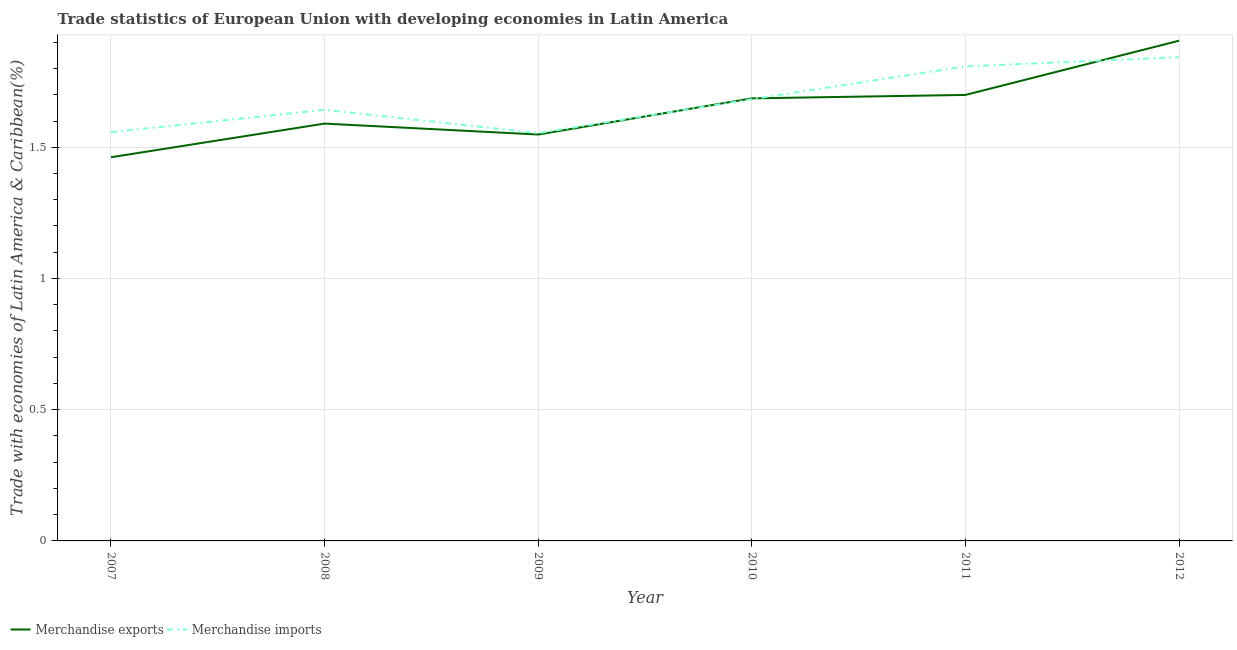How many different coloured lines are there?
Your answer should be compact. 2. What is the merchandise imports in 2010?
Provide a short and direct response. 1.68. Across all years, what is the maximum merchandise exports?
Keep it short and to the point. 1.91. Across all years, what is the minimum merchandise imports?
Your answer should be compact. 1.55. In which year was the merchandise exports minimum?
Make the answer very short. 2007. What is the total merchandise exports in the graph?
Provide a short and direct response. 9.89. What is the difference between the merchandise exports in 2009 and that in 2012?
Offer a very short reply. -0.36. What is the difference between the merchandise imports in 2007 and the merchandise exports in 2009?
Your answer should be very brief. 0.01. What is the average merchandise exports per year?
Your response must be concise. 1.65. In the year 2012, what is the difference between the merchandise exports and merchandise imports?
Your answer should be very brief. 0.06. What is the ratio of the merchandise imports in 2007 to that in 2012?
Offer a very short reply. 0.85. What is the difference between the highest and the second highest merchandise exports?
Provide a succinct answer. 0.21. What is the difference between the highest and the lowest merchandise imports?
Give a very brief answer. 0.29. Does the merchandise exports monotonically increase over the years?
Offer a very short reply. No. Is the merchandise imports strictly less than the merchandise exports over the years?
Make the answer very short. No. How many years are there in the graph?
Keep it short and to the point. 6. Are the values on the major ticks of Y-axis written in scientific E-notation?
Provide a succinct answer. No. Does the graph contain grids?
Keep it short and to the point. Yes. What is the title of the graph?
Offer a very short reply. Trade statistics of European Union with developing economies in Latin America. Does "Nonresident" appear as one of the legend labels in the graph?
Your answer should be compact. No. What is the label or title of the X-axis?
Make the answer very short. Year. What is the label or title of the Y-axis?
Your answer should be very brief. Trade with economies of Latin America & Caribbean(%). What is the Trade with economies of Latin America & Caribbean(%) of Merchandise exports in 2007?
Make the answer very short. 1.46. What is the Trade with economies of Latin America & Caribbean(%) in Merchandise imports in 2007?
Provide a succinct answer. 1.56. What is the Trade with economies of Latin America & Caribbean(%) of Merchandise exports in 2008?
Your answer should be very brief. 1.59. What is the Trade with economies of Latin America & Caribbean(%) of Merchandise imports in 2008?
Make the answer very short. 1.64. What is the Trade with economies of Latin America & Caribbean(%) in Merchandise exports in 2009?
Your response must be concise. 1.55. What is the Trade with economies of Latin America & Caribbean(%) in Merchandise imports in 2009?
Provide a short and direct response. 1.55. What is the Trade with economies of Latin America & Caribbean(%) of Merchandise exports in 2010?
Give a very brief answer. 1.69. What is the Trade with economies of Latin America & Caribbean(%) in Merchandise imports in 2010?
Keep it short and to the point. 1.68. What is the Trade with economies of Latin America & Caribbean(%) of Merchandise exports in 2011?
Give a very brief answer. 1.7. What is the Trade with economies of Latin America & Caribbean(%) of Merchandise imports in 2011?
Make the answer very short. 1.81. What is the Trade with economies of Latin America & Caribbean(%) of Merchandise exports in 2012?
Make the answer very short. 1.91. What is the Trade with economies of Latin America & Caribbean(%) in Merchandise imports in 2012?
Provide a succinct answer. 1.84. Across all years, what is the maximum Trade with economies of Latin America & Caribbean(%) of Merchandise exports?
Your answer should be compact. 1.91. Across all years, what is the maximum Trade with economies of Latin America & Caribbean(%) in Merchandise imports?
Offer a terse response. 1.84. Across all years, what is the minimum Trade with economies of Latin America & Caribbean(%) in Merchandise exports?
Keep it short and to the point. 1.46. Across all years, what is the minimum Trade with economies of Latin America & Caribbean(%) in Merchandise imports?
Offer a terse response. 1.55. What is the total Trade with economies of Latin America & Caribbean(%) of Merchandise exports in the graph?
Your answer should be very brief. 9.89. What is the total Trade with economies of Latin America & Caribbean(%) of Merchandise imports in the graph?
Keep it short and to the point. 10.09. What is the difference between the Trade with economies of Latin America & Caribbean(%) in Merchandise exports in 2007 and that in 2008?
Keep it short and to the point. -0.13. What is the difference between the Trade with economies of Latin America & Caribbean(%) of Merchandise imports in 2007 and that in 2008?
Make the answer very short. -0.09. What is the difference between the Trade with economies of Latin America & Caribbean(%) in Merchandise exports in 2007 and that in 2009?
Your answer should be very brief. -0.09. What is the difference between the Trade with economies of Latin America & Caribbean(%) of Merchandise imports in 2007 and that in 2009?
Give a very brief answer. 0. What is the difference between the Trade with economies of Latin America & Caribbean(%) in Merchandise exports in 2007 and that in 2010?
Provide a short and direct response. -0.22. What is the difference between the Trade with economies of Latin America & Caribbean(%) of Merchandise imports in 2007 and that in 2010?
Give a very brief answer. -0.13. What is the difference between the Trade with economies of Latin America & Caribbean(%) of Merchandise exports in 2007 and that in 2011?
Keep it short and to the point. -0.24. What is the difference between the Trade with economies of Latin America & Caribbean(%) in Merchandise imports in 2007 and that in 2011?
Make the answer very short. -0.25. What is the difference between the Trade with economies of Latin America & Caribbean(%) of Merchandise exports in 2007 and that in 2012?
Make the answer very short. -0.44. What is the difference between the Trade with economies of Latin America & Caribbean(%) of Merchandise imports in 2007 and that in 2012?
Your response must be concise. -0.29. What is the difference between the Trade with economies of Latin America & Caribbean(%) in Merchandise exports in 2008 and that in 2009?
Give a very brief answer. 0.04. What is the difference between the Trade with economies of Latin America & Caribbean(%) of Merchandise imports in 2008 and that in 2009?
Give a very brief answer. 0.09. What is the difference between the Trade with economies of Latin America & Caribbean(%) in Merchandise exports in 2008 and that in 2010?
Your answer should be very brief. -0.1. What is the difference between the Trade with economies of Latin America & Caribbean(%) in Merchandise imports in 2008 and that in 2010?
Your response must be concise. -0.04. What is the difference between the Trade with economies of Latin America & Caribbean(%) of Merchandise exports in 2008 and that in 2011?
Offer a terse response. -0.11. What is the difference between the Trade with economies of Latin America & Caribbean(%) of Merchandise imports in 2008 and that in 2011?
Your answer should be compact. -0.17. What is the difference between the Trade with economies of Latin America & Caribbean(%) of Merchandise exports in 2008 and that in 2012?
Ensure brevity in your answer.  -0.32. What is the difference between the Trade with economies of Latin America & Caribbean(%) in Merchandise imports in 2008 and that in 2012?
Give a very brief answer. -0.2. What is the difference between the Trade with economies of Latin America & Caribbean(%) in Merchandise exports in 2009 and that in 2010?
Your answer should be compact. -0.14. What is the difference between the Trade with economies of Latin America & Caribbean(%) in Merchandise imports in 2009 and that in 2010?
Make the answer very short. -0.13. What is the difference between the Trade with economies of Latin America & Caribbean(%) of Merchandise exports in 2009 and that in 2011?
Offer a terse response. -0.15. What is the difference between the Trade with economies of Latin America & Caribbean(%) in Merchandise imports in 2009 and that in 2011?
Give a very brief answer. -0.25. What is the difference between the Trade with economies of Latin America & Caribbean(%) of Merchandise exports in 2009 and that in 2012?
Provide a succinct answer. -0.36. What is the difference between the Trade with economies of Latin America & Caribbean(%) of Merchandise imports in 2009 and that in 2012?
Keep it short and to the point. -0.29. What is the difference between the Trade with economies of Latin America & Caribbean(%) of Merchandise exports in 2010 and that in 2011?
Give a very brief answer. -0.01. What is the difference between the Trade with economies of Latin America & Caribbean(%) in Merchandise imports in 2010 and that in 2011?
Keep it short and to the point. -0.12. What is the difference between the Trade with economies of Latin America & Caribbean(%) in Merchandise exports in 2010 and that in 2012?
Your response must be concise. -0.22. What is the difference between the Trade with economies of Latin America & Caribbean(%) of Merchandise imports in 2010 and that in 2012?
Provide a short and direct response. -0.16. What is the difference between the Trade with economies of Latin America & Caribbean(%) in Merchandise exports in 2011 and that in 2012?
Provide a short and direct response. -0.21. What is the difference between the Trade with economies of Latin America & Caribbean(%) of Merchandise imports in 2011 and that in 2012?
Ensure brevity in your answer.  -0.04. What is the difference between the Trade with economies of Latin America & Caribbean(%) in Merchandise exports in 2007 and the Trade with economies of Latin America & Caribbean(%) in Merchandise imports in 2008?
Give a very brief answer. -0.18. What is the difference between the Trade with economies of Latin America & Caribbean(%) of Merchandise exports in 2007 and the Trade with economies of Latin America & Caribbean(%) of Merchandise imports in 2009?
Your answer should be compact. -0.09. What is the difference between the Trade with economies of Latin America & Caribbean(%) in Merchandise exports in 2007 and the Trade with economies of Latin America & Caribbean(%) in Merchandise imports in 2010?
Give a very brief answer. -0.22. What is the difference between the Trade with economies of Latin America & Caribbean(%) of Merchandise exports in 2007 and the Trade with economies of Latin America & Caribbean(%) of Merchandise imports in 2011?
Offer a terse response. -0.35. What is the difference between the Trade with economies of Latin America & Caribbean(%) of Merchandise exports in 2007 and the Trade with economies of Latin America & Caribbean(%) of Merchandise imports in 2012?
Give a very brief answer. -0.38. What is the difference between the Trade with economies of Latin America & Caribbean(%) in Merchandise exports in 2008 and the Trade with economies of Latin America & Caribbean(%) in Merchandise imports in 2009?
Your response must be concise. 0.04. What is the difference between the Trade with economies of Latin America & Caribbean(%) in Merchandise exports in 2008 and the Trade with economies of Latin America & Caribbean(%) in Merchandise imports in 2010?
Your response must be concise. -0.09. What is the difference between the Trade with economies of Latin America & Caribbean(%) in Merchandise exports in 2008 and the Trade with economies of Latin America & Caribbean(%) in Merchandise imports in 2011?
Ensure brevity in your answer.  -0.22. What is the difference between the Trade with economies of Latin America & Caribbean(%) in Merchandise exports in 2008 and the Trade with economies of Latin America & Caribbean(%) in Merchandise imports in 2012?
Your response must be concise. -0.25. What is the difference between the Trade with economies of Latin America & Caribbean(%) of Merchandise exports in 2009 and the Trade with economies of Latin America & Caribbean(%) of Merchandise imports in 2010?
Offer a very short reply. -0.13. What is the difference between the Trade with economies of Latin America & Caribbean(%) in Merchandise exports in 2009 and the Trade with economies of Latin America & Caribbean(%) in Merchandise imports in 2011?
Your answer should be very brief. -0.26. What is the difference between the Trade with economies of Latin America & Caribbean(%) of Merchandise exports in 2009 and the Trade with economies of Latin America & Caribbean(%) of Merchandise imports in 2012?
Provide a succinct answer. -0.29. What is the difference between the Trade with economies of Latin America & Caribbean(%) in Merchandise exports in 2010 and the Trade with economies of Latin America & Caribbean(%) in Merchandise imports in 2011?
Offer a terse response. -0.12. What is the difference between the Trade with economies of Latin America & Caribbean(%) of Merchandise exports in 2010 and the Trade with economies of Latin America & Caribbean(%) of Merchandise imports in 2012?
Provide a succinct answer. -0.16. What is the difference between the Trade with economies of Latin America & Caribbean(%) in Merchandise exports in 2011 and the Trade with economies of Latin America & Caribbean(%) in Merchandise imports in 2012?
Your answer should be compact. -0.14. What is the average Trade with economies of Latin America & Caribbean(%) of Merchandise exports per year?
Provide a succinct answer. 1.65. What is the average Trade with economies of Latin America & Caribbean(%) of Merchandise imports per year?
Your response must be concise. 1.68. In the year 2007, what is the difference between the Trade with economies of Latin America & Caribbean(%) in Merchandise exports and Trade with economies of Latin America & Caribbean(%) in Merchandise imports?
Your response must be concise. -0.1. In the year 2008, what is the difference between the Trade with economies of Latin America & Caribbean(%) in Merchandise exports and Trade with economies of Latin America & Caribbean(%) in Merchandise imports?
Your response must be concise. -0.05. In the year 2009, what is the difference between the Trade with economies of Latin America & Caribbean(%) of Merchandise exports and Trade with economies of Latin America & Caribbean(%) of Merchandise imports?
Give a very brief answer. -0.01. In the year 2010, what is the difference between the Trade with economies of Latin America & Caribbean(%) in Merchandise exports and Trade with economies of Latin America & Caribbean(%) in Merchandise imports?
Your response must be concise. 0. In the year 2011, what is the difference between the Trade with economies of Latin America & Caribbean(%) in Merchandise exports and Trade with economies of Latin America & Caribbean(%) in Merchandise imports?
Your response must be concise. -0.11. In the year 2012, what is the difference between the Trade with economies of Latin America & Caribbean(%) in Merchandise exports and Trade with economies of Latin America & Caribbean(%) in Merchandise imports?
Offer a terse response. 0.06. What is the ratio of the Trade with economies of Latin America & Caribbean(%) of Merchandise exports in 2007 to that in 2008?
Give a very brief answer. 0.92. What is the ratio of the Trade with economies of Latin America & Caribbean(%) of Merchandise imports in 2007 to that in 2008?
Make the answer very short. 0.95. What is the ratio of the Trade with economies of Latin America & Caribbean(%) in Merchandise exports in 2007 to that in 2009?
Make the answer very short. 0.94. What is the ratio of the Trade with economies of Latin America & Caribbean(%) in Merchandise exports in 2007 to that in 2010?
Make the answer very short. 0.87. What is the ratio of the Trade with economies of Latin America & Caribbean(%) in Merchandise imports in 2007 to that in 2010?
Provide a short and direct response. 0.93. What is the ratio of the Trade with economies of Latin America & Caribbean(%) in Merchandise exports in 2007 to that in 2011?
Give a very brief answer. 0.86. What is the ratio of the Trade with economies of Latin America & Caribbean(%) of Merchandise imports in 2007 to that in 2011?
Your response must be concise. 0.86. What is the ratio of the Trade with economies of Latin America & Caribbean(%) in Merchandise exports in 2007 to that in 2012?
Your answer should be very brief. 0.77. What is the ratio of the Trade with economies of Latin America & Caribbean(%) of Merchandise imports in 2007 to that in 2012?
Offer a terse response. 0.84. What is the ratio of the Trade with economies of Latin America & Caribbean(%) of Merchandise exports in 2008 to that in 2009?
Provide a short and direct response. 1.03. What is the ratio of the Trade with economies of Latin America & Caribbean(%) of Merchandise imports in 2008 to that in 2009?
Offer a very short reply. 1.06. What is the ratio of the Trade with economies of Latin America & Caribbean(%) in Merchandise exports in 2008 to that in 2010?
Your answer should be compact. 0.94. What is the ratio of the Trade with economies of Latin America & Caribbean(%) in Merchandise imports in 2008 to that in 2010?
Offer a terse response. 0.98. What is the ratio of the Trade with economies of Latin America & Caribbean(%) in Merchandise exports in 2008 to that in 2011?
Provide a succinct answer. 0.94. What is the ratio of the Trade with economies of Latin America & Caribbean(%) of Merchandise imports in 2008 to that in 2011?
Your answer should be very brief. 0.91. What is the ratio of the Trade with economies of Latin America & Caribbean(%) in Merchandise exports in 2008 to that in 2012?
Provide a succinct answer. 0.83. What is the ratio of the Trade with economies of Latin America & Caribbean(%) in Merchandise imports in 2008 to that in 2012?
Offer a terse response. 0.89. What is the ratio of the Trade with economies of Latin America & Caribbean(%) in Merchandise exports in 2009 to that in 2010?
Your answer should be compact. 0.92. What is the ratio of the Trade with economies of Latin America & Caribbean(%) in Merchandise imports in 2009 to that in 2010?
Make the answer very short. 0.92. What is the ratio of the Trade with economies of Latin America & Caribbean(%) of Merchandise exports in 2009 to that in 2011?
Make the answer very short. 0.91. What is the ratio of the Trade with economies of Latin America & Caribbean(%) of Merchandise imports in 2009 to that in 2011?
Offer a terse response. 0.86. What is the ratio of the Trade with economies of Latin America & Caribbean(%) in Merchandise exports in 2009 to that in 2012?
Keep it short and to the point. 0.81. What is the ratio of the Trade with economies of Latin America & Caribbean(%) in Merchandise imports in 2009 to that in 2012?
Make the answer very short. 0.84. What is the ratio of the Trade with economies of Latin America & Caribbean(%) in Merchandise exports in 2010 to that in 2011?
Provide a short and direct response. 0.99. What is the ratio of the Trade with economies of Latin America & Caribbean(%) of Merchandise imports in 2010 to that in 2011?
Provide a short and direct response. 0.93. What is the ratio of the Trade with economies of Latin America & Caribbean(%) in Merchandise exports in 2010 to that in 2012?
Provide a succinct answer. 0.88. What is the ratio of the Trade with economies of Latin America & Caribbean(%) in Merchandise imports in 2010 to that in 2012?
Your answer should be compact. 0.91. What is the ratio of the Trade with economies of Latin America & Caribbean(%) in Merchandise exports in 2011 to that in 2012?
Your answer should be very brief. 0.89. What is the difference between the highest and the second highest Trade with economies of Latin America & Caribbean(%) of Merchandise exports?
Provide a succinct answer. 0.21. What is the difference between the highest and the second highest Trade with economies of Latin America & Caribbean(%) in Merchandise imports?
Ensure brevity in your answer.  0.04. What is the difference between the highest and the lowest Trade with economies of Latin America & Caribbean(%) of Merchandise exports?
Provide a short and direct response. 0.44. What is the difference between the highest and the lowest Trade with economies of Latin America & Caribbean(%) of Merchandise imports?
Your response must be concise. 0.29. 